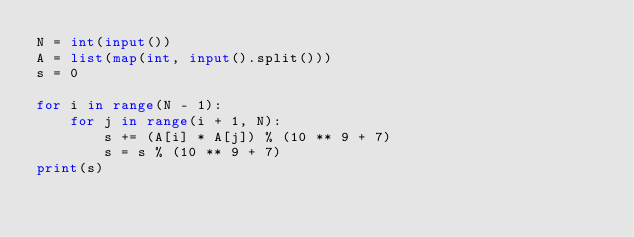<code> <loc_0><loc_0><loc_500><loc_500><_Python_>N = int(input())
A = list(map(int, input().split()))
s = 0

for i in range(N - 1):
	for j in range(i + 1, N):
		s += (A[i] * A[j]) % (10 ** 9 + 7)
		s = s % (10 ** 9 + 7)
print(s)</code> 